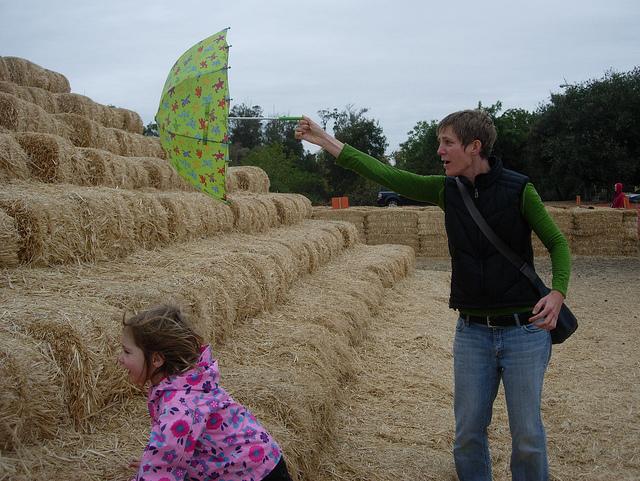What is the child climbing on?
Concise answer only. Hay. Is it raining in the picture?
Be succinct. No. Is the child smiling?
Short answer required. Yes. 